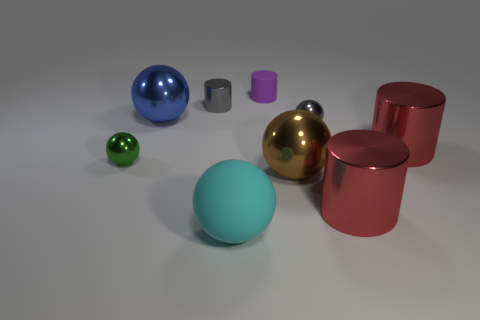Can you describe the lighting source and how it affects the appearance of the objects? The lighting in the image appears to be overhead, possibly from a single source due to the focused shadows cast by the objects. This illumination creates distinct highlights and contributes to the realism by enhancing the metallic surfaces and the shadows on the ground. 